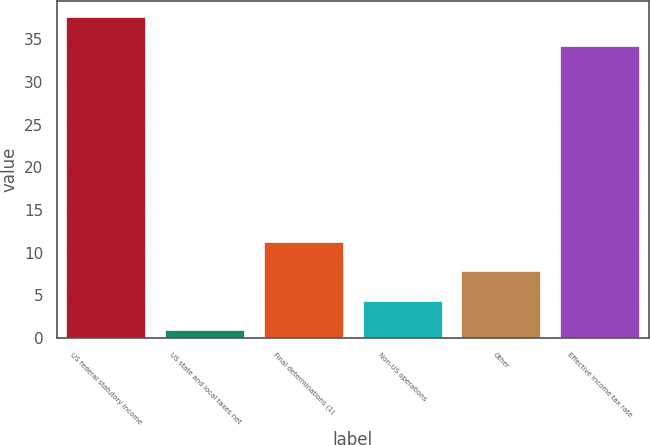Convert chart to OTSL. <chart><loc_0><loc_0><loc_500><loc_500><bar_chart><fcel>US federal statutory income<fcel>US state and local taxes net<fcel>Final determinations (1)<fcel>Non-US operations<fcel>Other<fcel>Effective income tax rate<nl><fcel>37.6<fcel>1<fcel>11.2<fcel>4.4<fcel>7.8<fcel>34.2<nl></chart> 